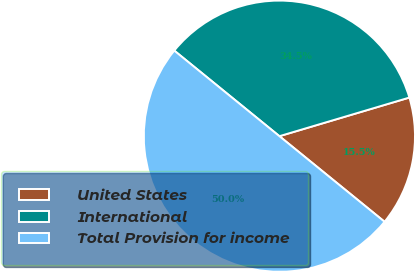Convert chart to OTSL. <chart><loc_0><loc_0><loc_500><loc_500><pie_chart><fcel>United States<fcel>International<fcel>Total Provision for income<nl><fcel>15.47%<fcel>34.53%<fcel>50.0%<nl></chart> 